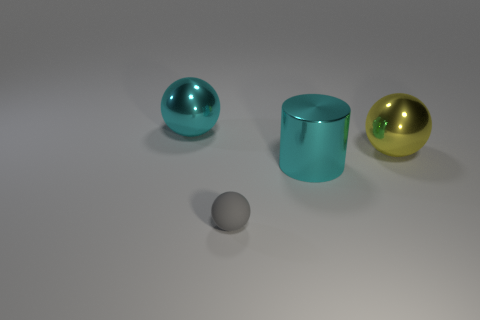Add 3 gray things. How many objects exist? 7 Subtract all cylinders. How many objects are left? 3 Add 1 yellow metal objects. How many yellow metal objects are left? 2 Add 4 tiny brown matte spheres. How many tiny brown matte spheres exist? 4 Subtract 0 gray blocks. How many objects are left? 4 Subtract all large yellow metallic blocks. Subtract all large cyan cylinders. How many objects are left? 3 